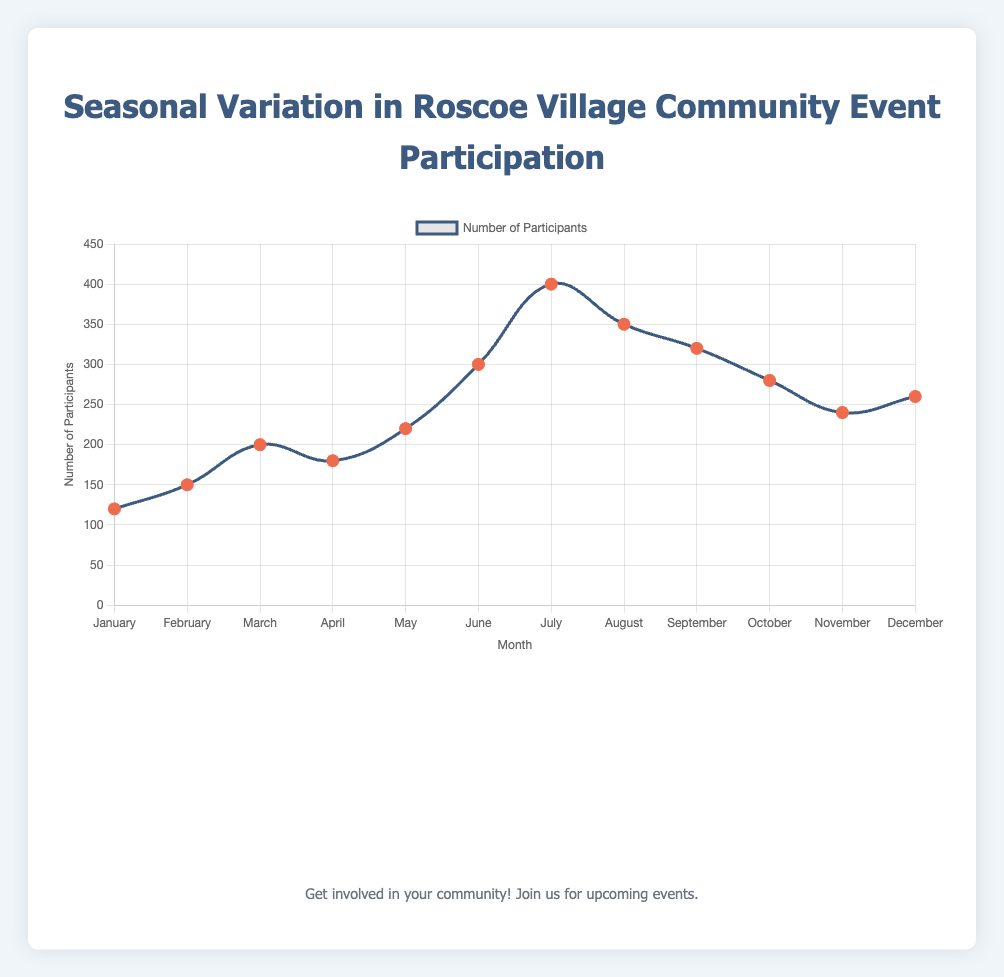What is the event with the highest number of participants? Look for the highest data point on the line chart. The highest peak is in July. The tooltip will show "4th of July Fireworks" with 400 participants as the event.
Answer: 4th of July Fireworks How many participants attended the events in January and December combined? Check the participants for January (120) and December (260). Sum these values to get the combined total: 120 + 260.
Answer: 380 Which month saw a decrease in event participation after a peak in the previous month? Identify peaks and the subsequent months. After the highest peak in July (400), August’s participation decreases to 350.
Answer: August Is the participation trend generally increasing, decreasing, or fluctuating throughout the year? Observe the line chart for an overall pattern. The participation starts low, peaks in summer, and gradually decreases towards the end of the year. This indicates a fluctuating pattern.
Answer: Fluctuating During which month did the event "Back to School Festival" take place, and how many participants were there? By consulting the tooltips or the legend, find September, which states "Back to School Festival" with 320 participants.
Answer: September, 320 Which event had more participants: "Spring Clean-Up" or "Halloween Spooktacular"? Compare the participants for April (Spring Clean-Up, 180) and October (Halloween Spooktacular, 280). October has more participants.
Answer: Halloween Spooktacular What is the average number of participants per month for the entire year? Sum all participants: 120 + 150 + 200 + 180 + 220 + 300 + 400 + 350 + 320 + 280 + 240 + 260 = 3020. Divide by 12 (the number of months): 3020 / 12.
Answer: 251.67 Which event followed "St. Patrick's Day Parade" in terms of participation, and how many more participants did it have? "St. Patrick's Day Parade" is in March (200 participants). "Spring Clean-Up" in April follows with 180 participants. Calculate the difference: 200 - 180.
Answer: "Spring Clean-Up", 20 less Identify the event with the second-highest participation and its month. Find the second-highest peak on the chart, which is 350 in August for "Summer Block Party".
Answer: Summer Block Party, August What was the total participation for events held in the summer months (June, July, and August)? Sum the participants for June (300), July (400), and August (350): 300 + 400 + 350.
Answer: 1050 